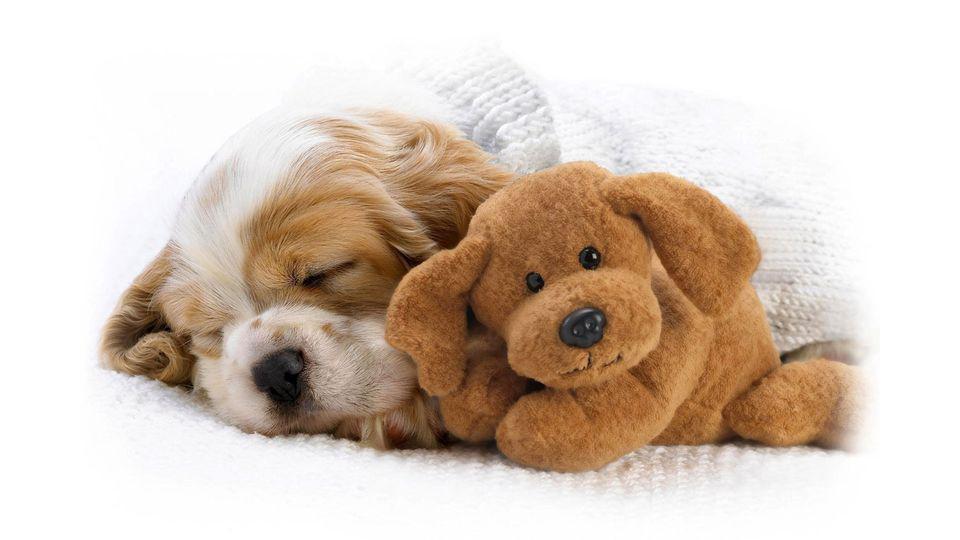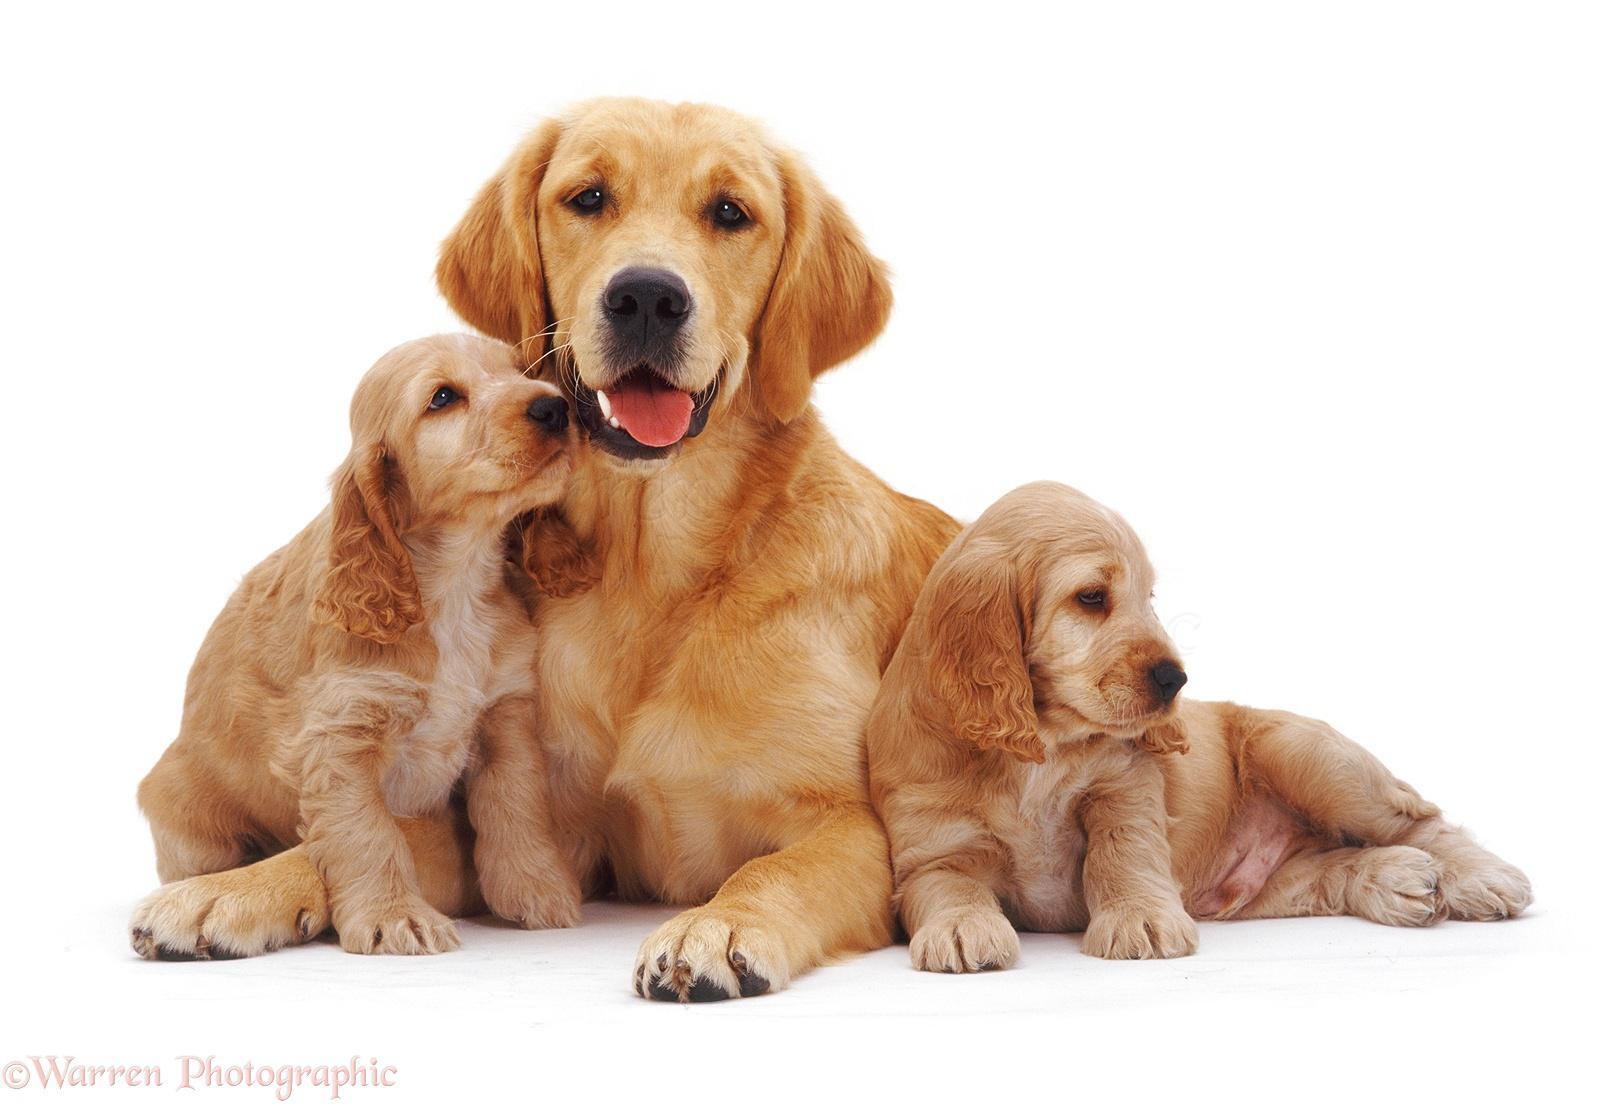The first image is the image on the left, the second image is the image on the right. Analyze the images presented: Is the assertion "There are no more than 3 dogs." valid? Answer yes or no. No. The first image is the image on the left, the second image is the image on the right. Analyze the images presented: Is the assertion "The right image contains exactly three dogs." valid? Answer yes or no. Yes. 